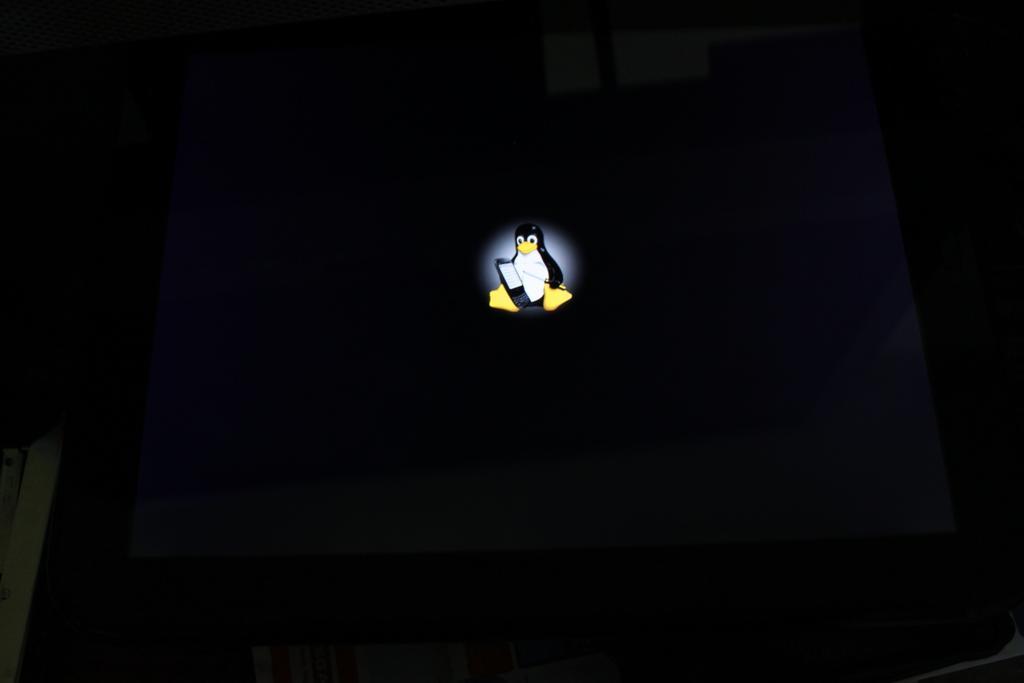In one or two sentences, can you explain what this image depicts? This is penguin, this is black color. 